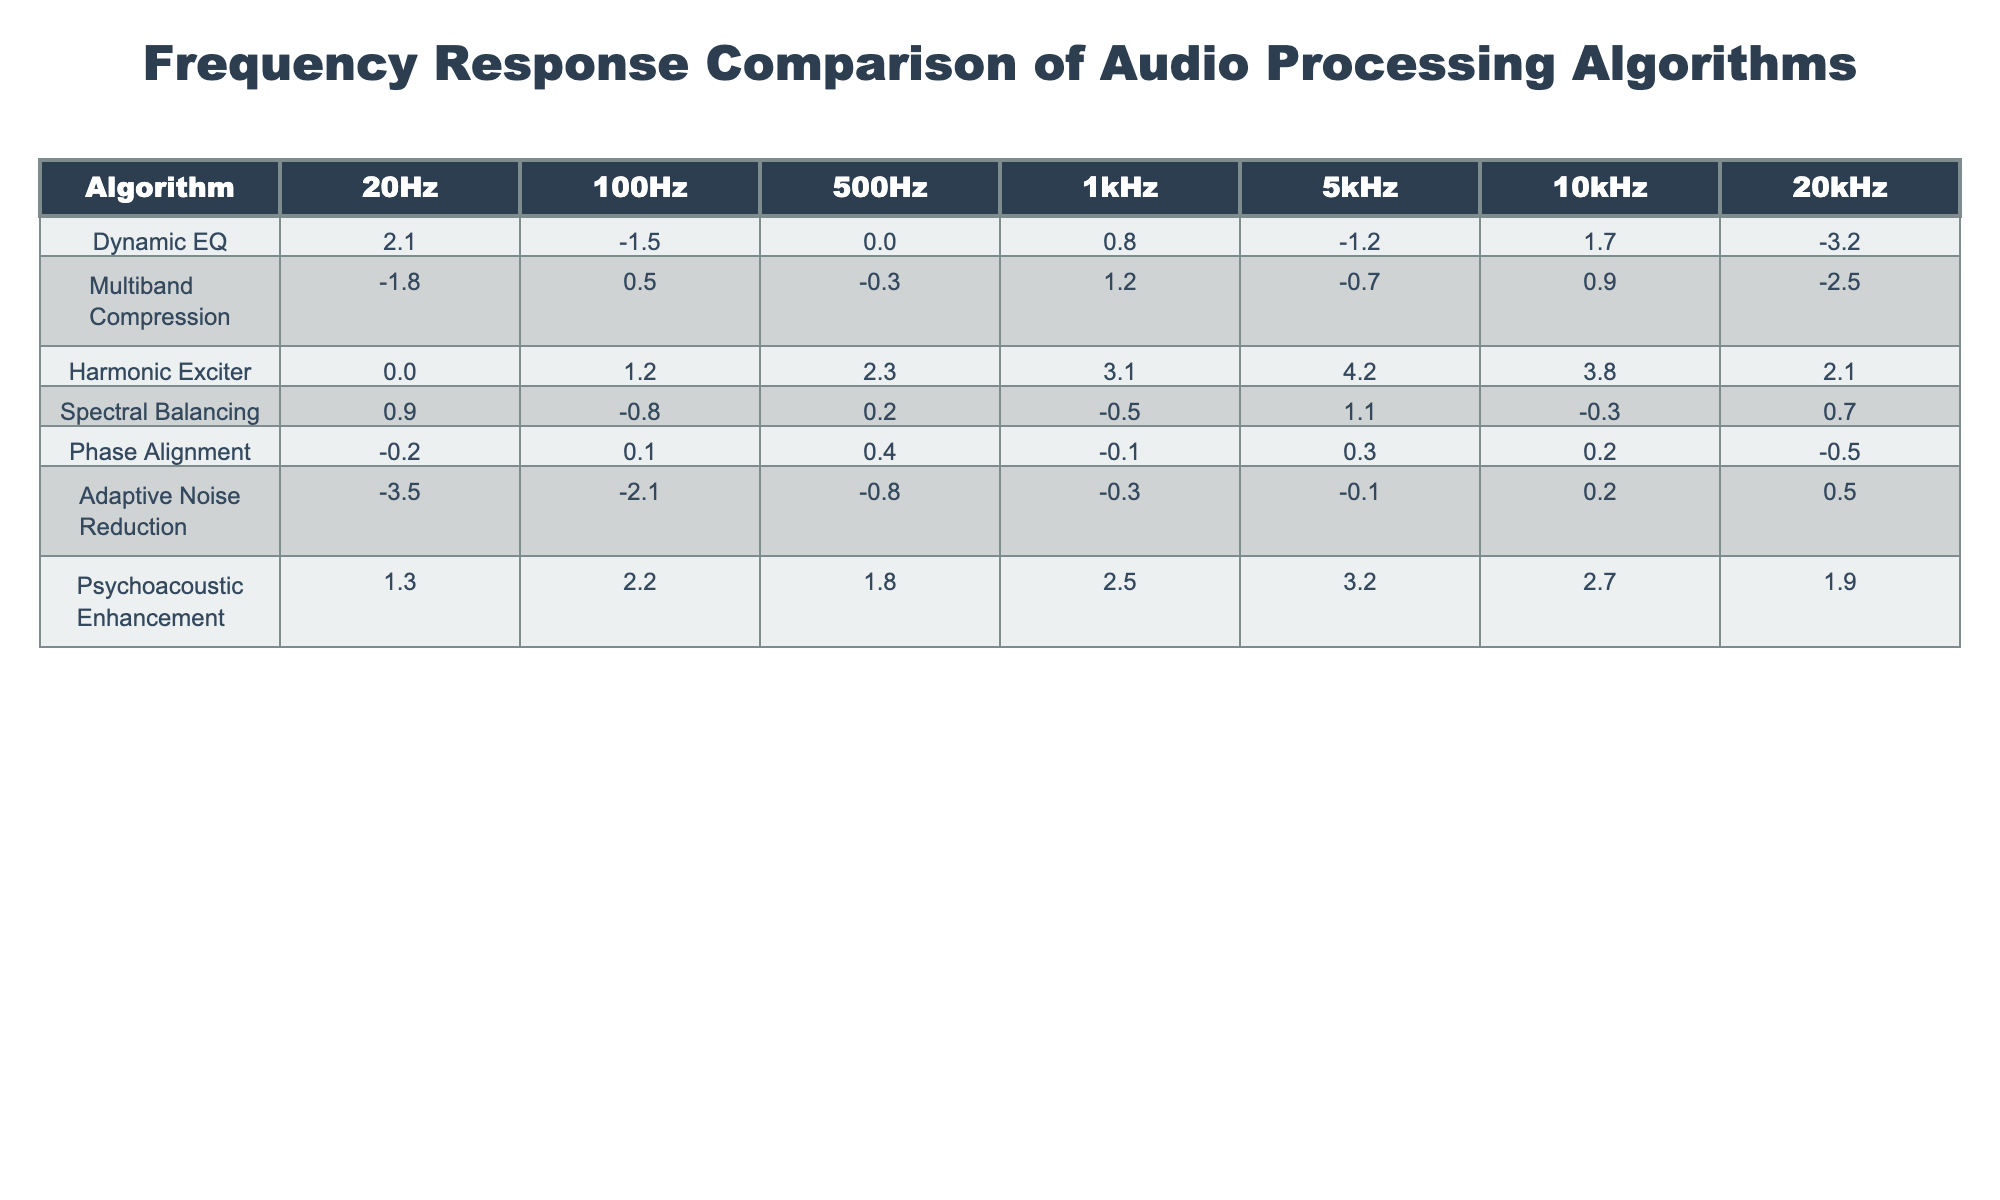What is the frequency response of the Harmonic Exciter at 1kHz? According to the table, the Harmonic Exciter has a frequency response of +3.1 dB at 1kHz.
Answer: +3.1 dB Which algorithm shows the highest frequency response at 5kHz? By inspecting the table, the Psychoacoustic Enhancement algorithm has the highest frequency response at 5kHz with +3.2 dB.
Answer: Psychoacoustic Enhancement What is the average frequency response of the Dynamic EQ across all frequencies? First, we sum the frequency responses of Dynamic EQ: (+2.1) + (-1.5) + (0.0) + (+0.8) + (-1.2) + (+1.7) + (-3.2) = -1.3. Then, we divide by the number of frequencies (7): -1.3 / 7 = approximately -0.18 dB.
Answer: -0.18 dB Is there any algorithm that improves the frequency response at all measured frequencies (20Hz, 100Hz, 500Hz, 1kHz, 5kHz, 10kHz, 20kHz)? We need to check each algorithm for all frequencies to see if they all have positive values. The only algorithm that does not have any negatives is the Harmonic Exciter, which has all positive values across the measured bands.
Answer: Yes, Harmonic Exciter For which frequencies does the Adaptive Noise Reduction algorithm have negative values? By examining the table, Adaptive Noise Reduction has negative values at 20Hz (-3.5 dB), 100Hz (-2.1 dB), 500Hz (-0.8 dB), while at 1kHz, 5kHz, 10kHz, and 20kHz, it has 0.3, 0.1, and 0.5 that are not negative.
Answer: 20Hz, 100Hz, 500Hz What is the difference in frequency response between Psychoacoustic Enhancement and Multiband Compression at 500Hz? For Psychoacoustic Enhancement, the response at 500Hz is +1.8 dB and for Multiband Compression it is -0.3 dB. The difference is (+1.8) - (-0.3) = +2.1 dB.
Answer: +2.1 dB Which algorithm has the lowest value at 10kHz? Looking at the table, the algorithm that has the lowest frequency response at 10kHz is the Adaptive Noise Reduction with +0.2 dB.
Answer: Adaptive Noise Reduction What is the sum of the frequency responses for the Spectral Balancing algorithm at 20Hz and 20kHz? Spectral Balancing shows +0.9 dB at 20Hz and +0.7 dB at 20kHz. Summing these: +0.9 + +0.7 = +1.6 dB.
Answer: +1.6 dB Which algorithm demonstrates the largest variation between its maximum and minimum responses across all frequencies? We compare the maximum and minimum responses for each algorithm. The Psychoacoustic Enhancement shows a maximum of +3.2 dB (at 5kHz) and a minimum of +1.8 dB (at 20kHz), resulting in a variation of 3.2 - 1.9 = 1.3 dB. Other algorithms show variations less than this.
Answer: Psychoacoustic Enhancement Does the Dynamic EQ algorithm provide a positive frequency response at 10kHz? The response for Dynamic EQ at 10kHz is +1.7 dB, which is indeed a positive value.
Answer: Yes 